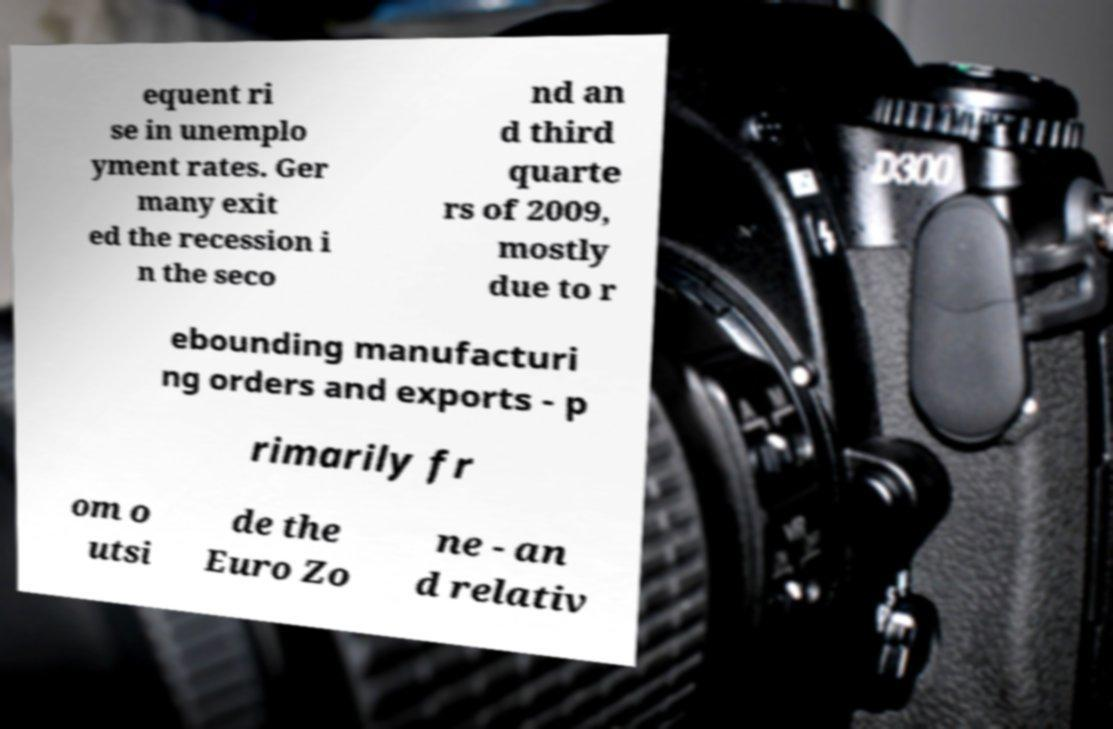Can you read and provide the text displayed in the image?This photo seems to have some interesting text. Can you extract and type it out for me? equent ri se in unemplo yment rates. Ger many exit ed the recession i n the seco nd an d third quarte rs of 2009, mostly due to r ebounding manufacturi ng orders and exports - p rimarily fr om o utsi de the Euro Zo ne - an d relativ 